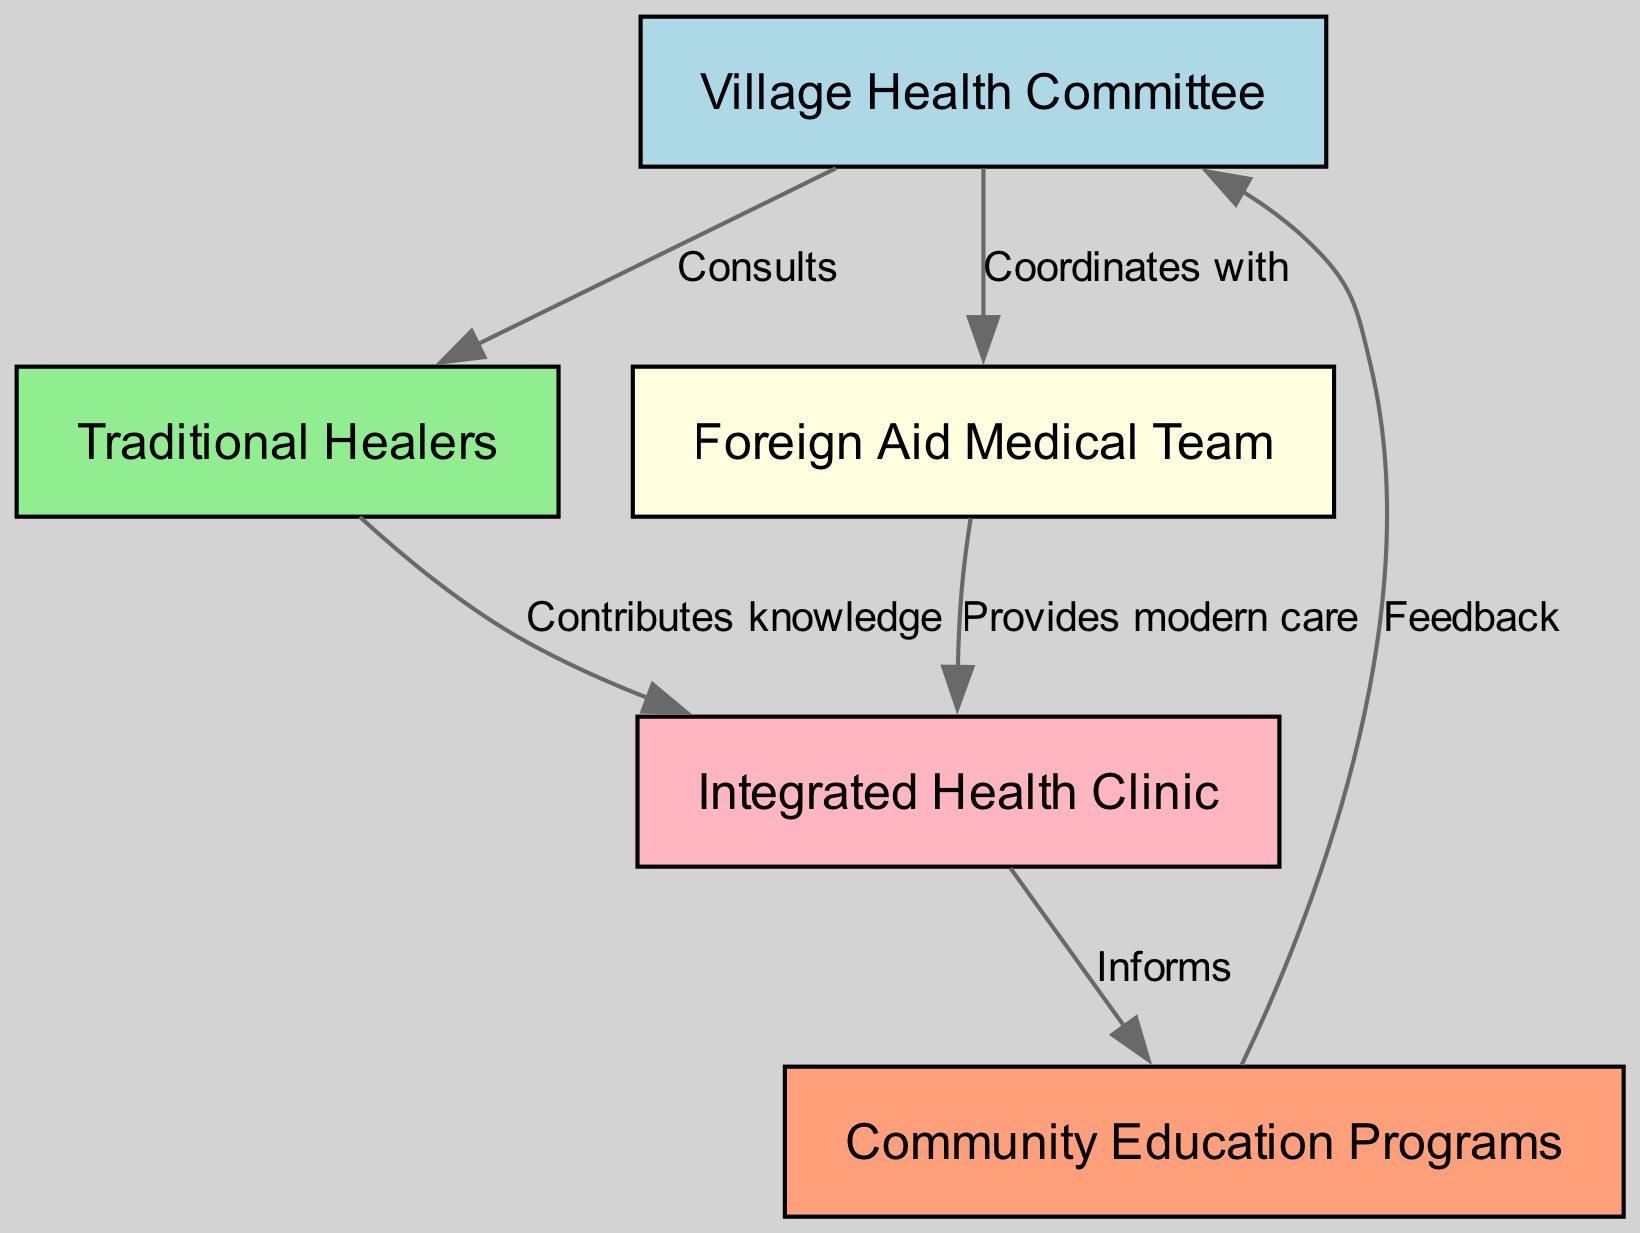What is the role of the Village Health Committee? The Village Health Committee consults with Traditional Healers and coordinates with the Foreign Aid Medical Team. Its primary role is at the center of communication and integration between different health care providers.
Answer: Consults How many nodes are in the diagram? To find the total number of nodes, we can count each unique node present in the diagram. There are five nodes: Village Health Committee, Traditional Healers, Foreign Aid Medical Team, Integrated Health Clinic, and Community Education Programs.
Answer: Five What action links the Traditional Healers to the Integrated Health Clinic? The edge from Traditional Healers to Integrated Health Clinic is labeled "Contributes knowledge," indicating the nature of their relationship and the flow of information.
Answer: Contributes knowledge Who provides modern care in the system? The Foreign Aid Medical Team is directly connected to the Integrated Health Clinic and is labeled as providing modern care, indicating its role in offering contemporary health interventions.
Answer: Foreign Aid Medical Team What does the Integrated Health Clinic inform? The Integrated Health Clinic is shown to inform Community Education Programs, suggesting that it relays important health information and practices to enhance community awareness and education.
Answer: Community Education Programs How does feedback flow in the system? Feedback flows from Community Education Programs back to the Village Health Committee, indicating an iterative process where community responses are considered by the health committee to improve health services.
Answer: Feedback What is the relationship between the Foreign Aid Medical Team and the Village Health Committee? The Foreign Aid Medical Team coordinates with the Village Health Committee, illustrating a collaborative approach to healthcare management in the village.
Answer: Coordinates with Which entity contributes knowledge to the Integrated Health Clinic? Traditional Healers are indicated to contribute knowledge to the Integrated Health Clinic, showcasing the integration of traditional healing practices into the modern health system.
Answer: Traditional Healers In the diagram, how many edges are present? By counting the directed connections between the nodes, we see there are six edges, each representing a different relationship or interaction in the healthcare system.
Answer: Six 